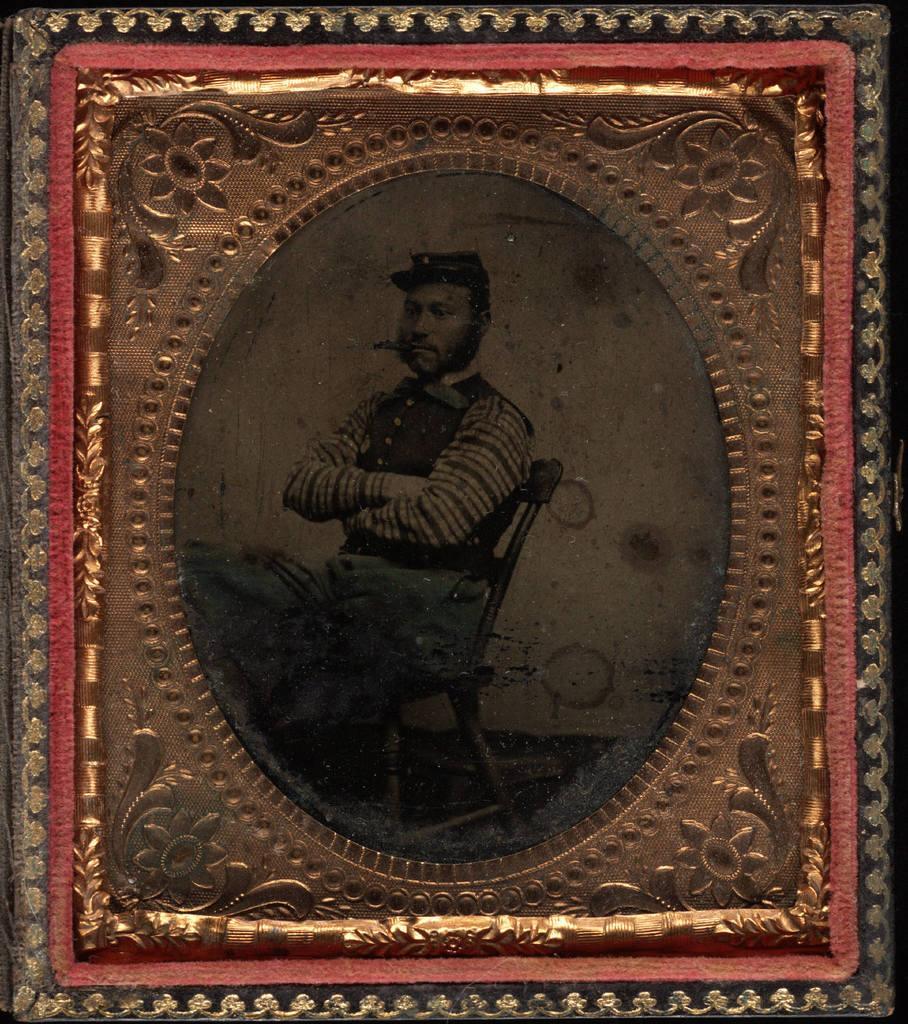Can you describe this image briefly? In this image we can see a picture frame of a person sitting on the chair and having a cigar in his mouth. 